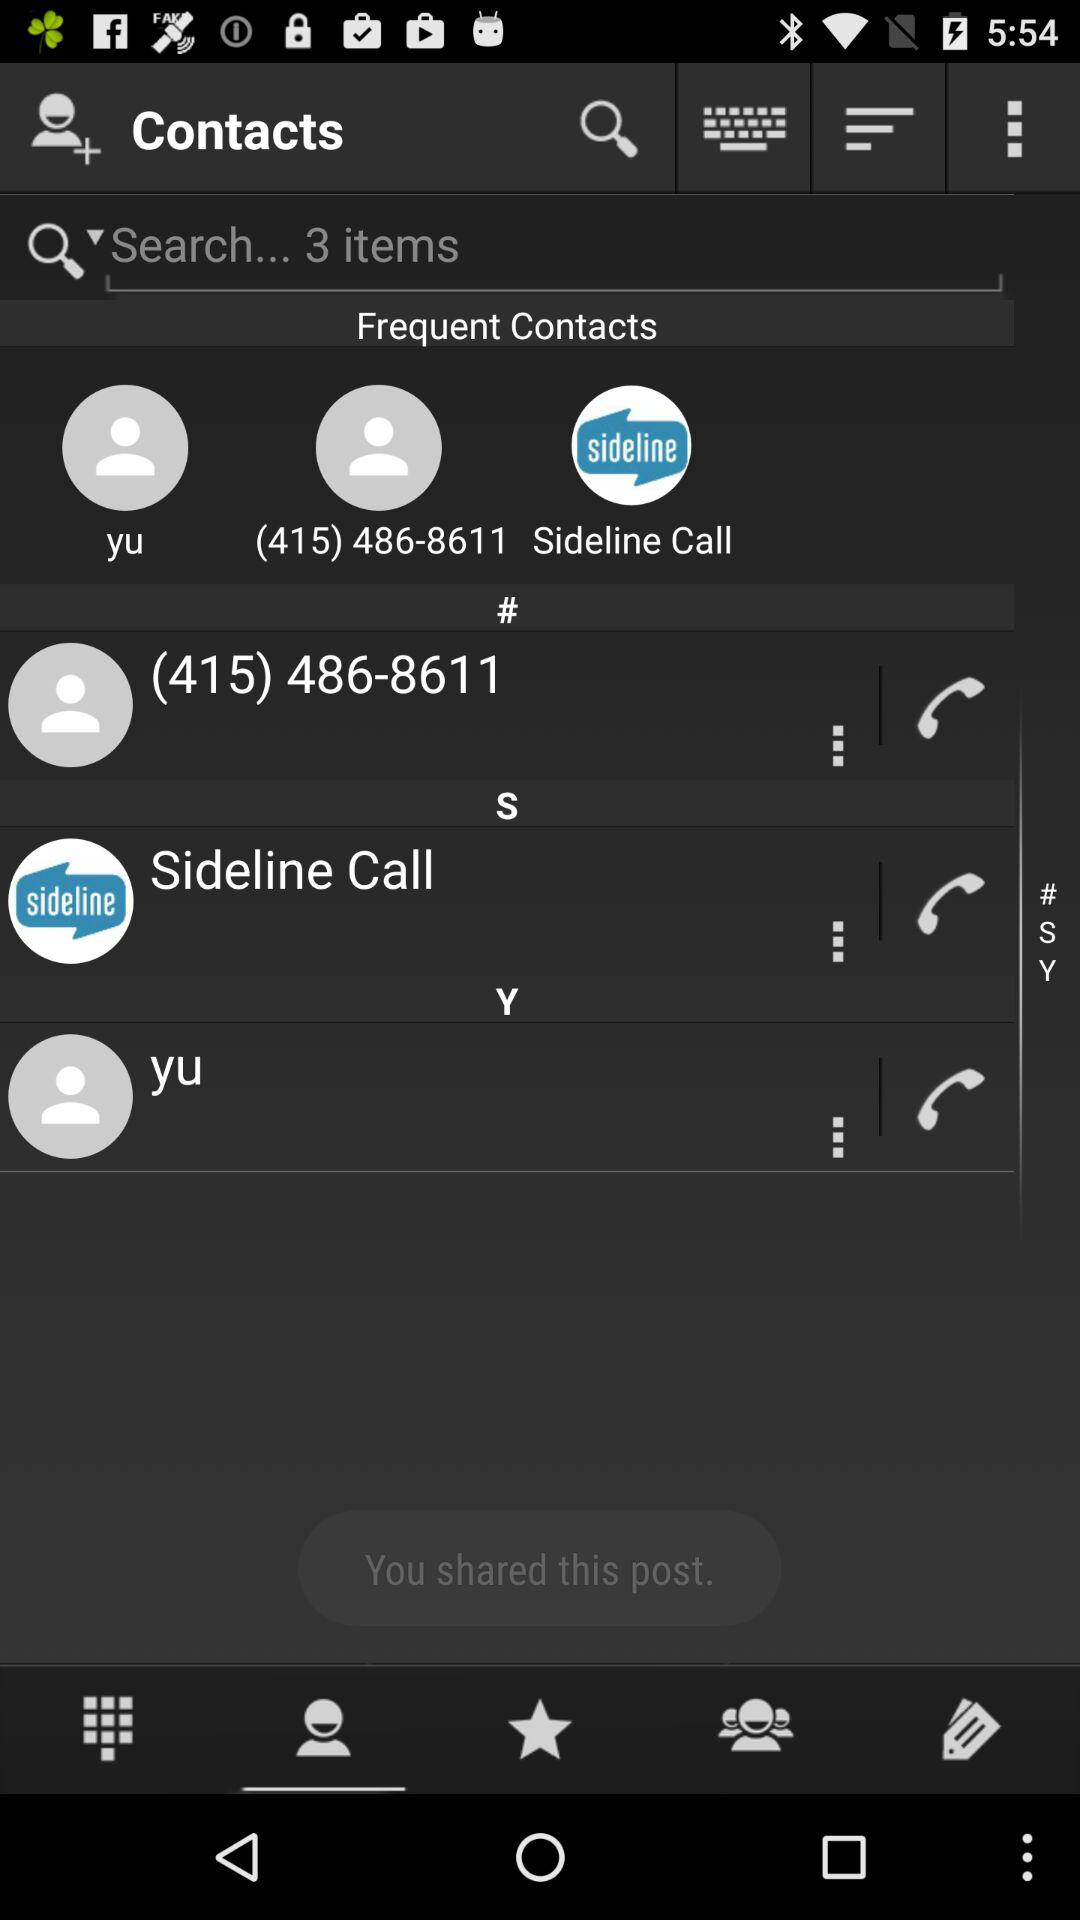What is the mobile number? The mobile number is (415) 486-8611. 